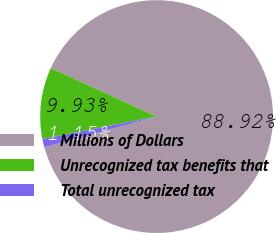Convert chart. <chart><loc_0><loc_0><loc_500><loc_500><pie_chart><fcel>Millions of Dollars<fcel>Unrecognized tax benefits that<fcel>Total unrecognized tax<nl><fcel>88.92%<fcel>9.93%<fcel>1.15%<nl></chart> 